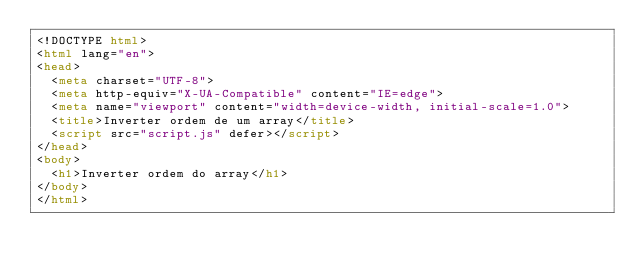<code> <loc_0><loc_0><loc_500><loc_500><_HTML_><!DOCTYPE html>
<html lang="en">
<head>
  <meta charset="UTF-8">
  <meta http-equiv="X-UA-Compatible" content="IE=edge">
  <meta name="viewport" content="width=device-width, initial-scale=1.0">
  <title>Inverter ordem de um array</title>
  <script src="script.js" defer></script>
</head>
<body>
  <h1>Inverter ordem do array</h1>
</body>
</html></code> 